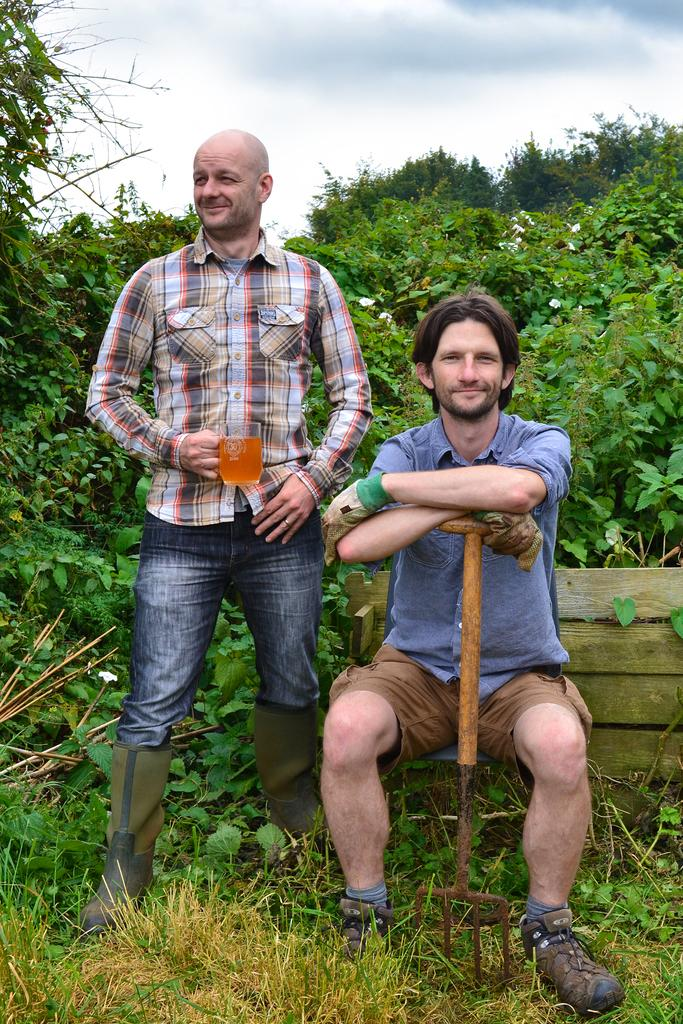What can be seen in the foreground of the picture? In the foreground of the picture, there are men, a bench, grass, and plants. What is the men's position in relation to the bench? The men are positioned in front of the bench. What type of vegetation is visible in the foreground of the picture? Grass and plants are visible in the foreground of the picture. What is visible in the background of the picture? In the background of the picture, there are trees and the sky. What type of rice is being served on the bench in the image? There is no rice present in the image; the bench is empty. How many toes are visible on the men in the image? The number of toes cannot be determined from the image, as feet are not visible. 